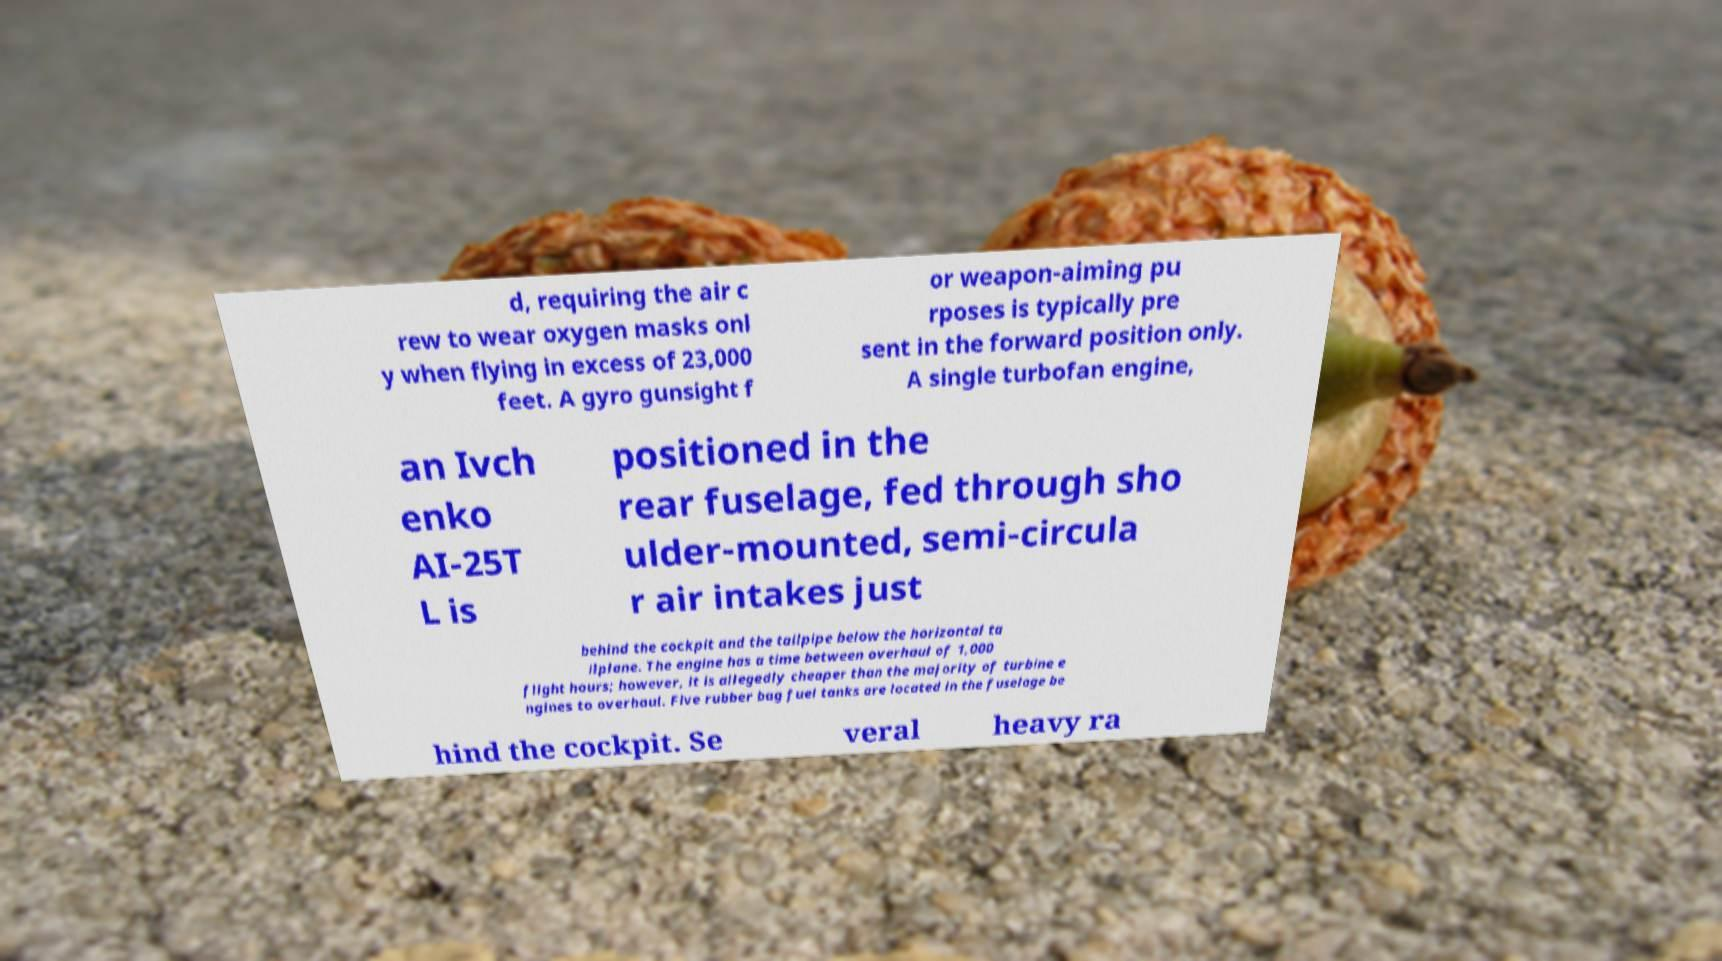Please read and relay the text visible in this image. What does it say? d, requiring the air c rew to wear oxygen masks onl y when flying in excess of 23,000 feet. A gyro gunsight f or weapon-aiming pu rposes is typically pre sent in the forward position only. A single turbofan engine, an Ivch enko AI-25T L is positioned in the rear fuselage, fed through sho ulder-mounted, semi-circula r air intakes just behind the cockpit and the tailpipe below the horizontal ta ilplane. The engine has a time between overhaul of 1,000 flight hours; however, it is allegedly cheaper than the majority of turbine e ngines to overhaul. Five rubber bag fuel tanks are located in the fuselage be hind the cockpit. Se veral heavy ra 